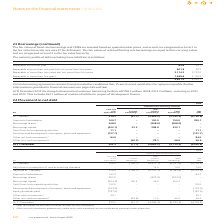According to Intu Properties's financial document, What is the amount of undrawn borrowing facilities at 31 December 2019? According to the financial document, £238.5 million. The relevant text states: "roup had committed undrawn borrowing facilities of £238.5 million (2018: £274.2 million), maturing in 2021 and 2022. This includes £42.1 million of undrawn facilities..." Also, What is the amount of undrawn facilities in respect of development finance? According to the financial document, £42.1 million. The relevant text states: "million), maturing in 2021 and 2022. This includes £42.1 million of undrawn facilities in respect of development finance...." Also, What is the amount of debt repayable within one year in 2019? According to the financial document, 65.8 (in millions). The relevant text states: "Repayable within one year 65.8 46.7..." Additionally, In which year is there a greater total debt? According to the financial document, 2018. The relevant text states: "£m 2019 2018..." Additionally, In which year is there a greater debt repayable in more than five years? According to the financial document, 2018. The relevant text states: "£m 2019 2018..." Also, can you calculate: What is the percentage change in the total debt from 2018 to 2019? To answer this question, I need to perform calculations using the financial data. The calculation is: (4,651.4-4,955.1)/4,955.1, which equals -6.13 (percentage). This is based on the information: "4,651.4 4,955.1 4,651.4 4,955.1..." The key data points involved are: 4,651.4, 4,955.1. 